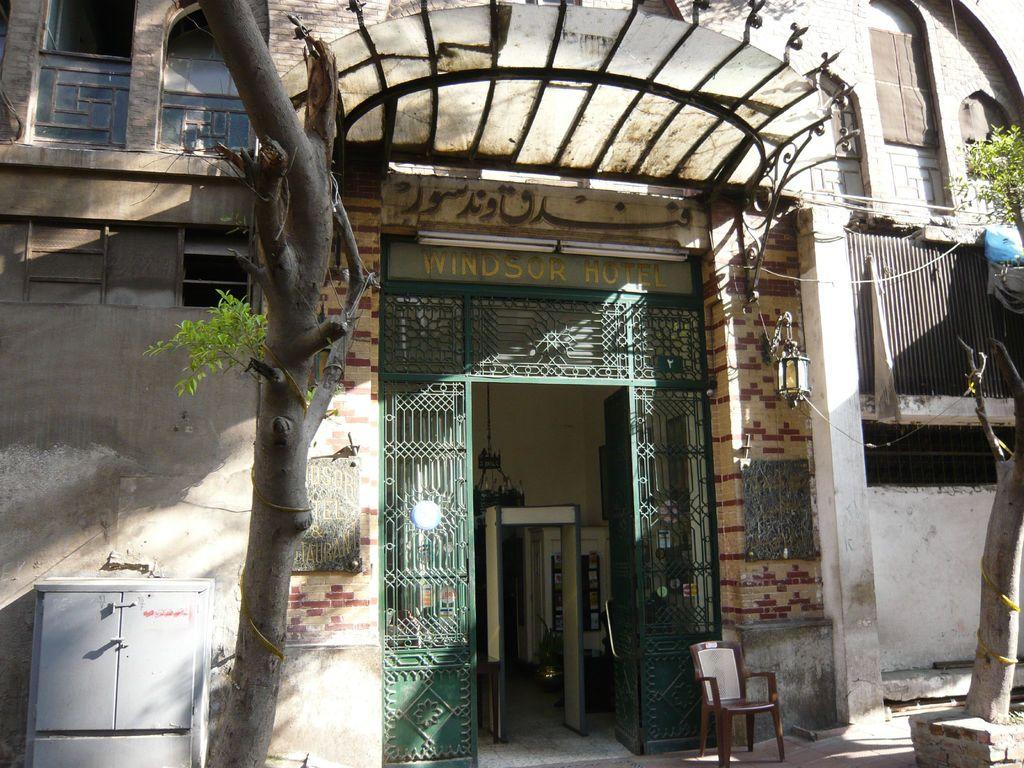What does it say above the doorway?
Offer a terse response. Windsor hotel. 